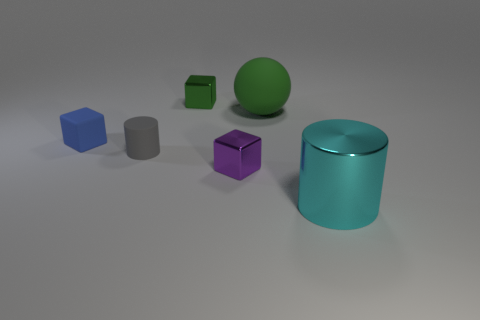What can you infer about the size relationships between the objects? The objects vary in size, with the teal cylinder being the largest. The green sphere and purple cube seem to be of a similar size, which is slightly smaller than the teal cylinder. The blue and the green cubes are the smallest objects shown. The gray cylinder appears to be of medium size relative to the others. 